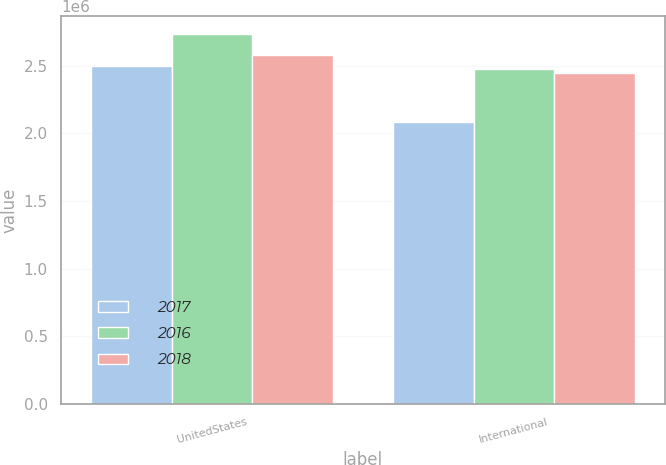Convert chart to OTSL. <chart><loc_0><loc_0><loc_500><loc_500><stacked_bar_chart><ecel><fcel>UnitedStates<fcel>International<nl><fcel>2017<fcel>2.49733e+06<fcel>2.08232e+06<nl><fcel>2016<fcel>2.73203e+06<fcel>2.47775e+06<nl><fcel>2018<fcel>2.5757e+06<fcel>2.44413e+06<nl></chart> 